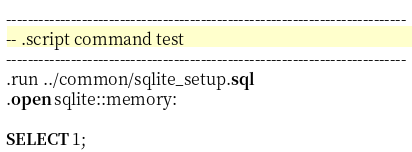Convert code to text. <code><loc_0><loc_0><loc_500><loc_500><_SQL_>--------------------------------------------------------------------------
-- .script command test
--------------------------------------------------------------------------
.run ../common/sqlite_setup.sql
.open sqlite::memory:

SELECT 1;
</code> 